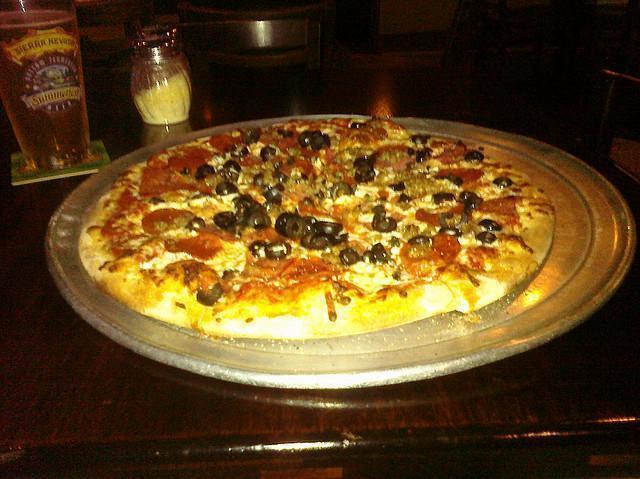What is in the shaker jar next to the beverage?
Pick the correct solution from the four options below to address the question.
Options: Hot peppers, parmesan cheese, sugar, salt. Parmesan cheese. 